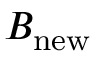<formula> <loc_0><loc_0><loc_500><loc_500>B _ { n e w }</formula> 